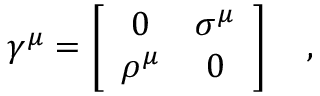Convert formula to latex. <formula><loc_0><loc_0><loc_500><loc_500>\gamma ^ { \mu } = \left [ \begin{array} { c c } { 0 } & { { \sigma ^ { \mu } } } \\ { { \rho ^ { \mu } } } & { 0 } \end{array} \right ] \quad ,</formula> 